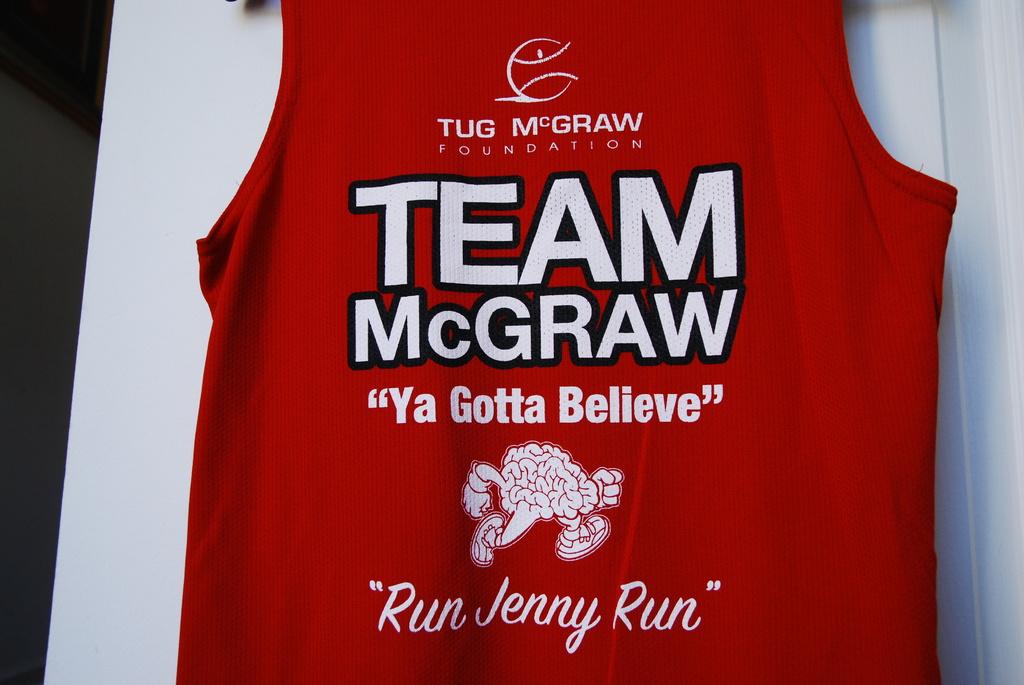What tagline does team mcgraw use?
Ensure brevity in your answer.  Ya gotta believe. Which foundation does the shirt support?
Offer a very short reply. Tug mcgraw. 